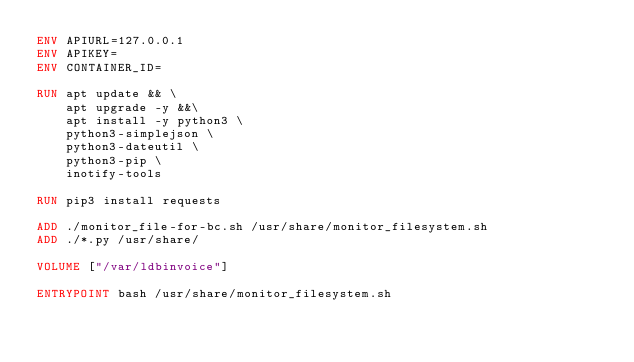<code> <loc_0><loc_0><loc_500><loc_500><_Dockerfile_>ENV APIURL=127.0.0.1
ENV APIKEY=
ENV CONTAINER_ID=

RUN apt update && \
    apt upgrade -y &&\
    apt install -y python3 \
	python3-simplejson \
	python3-dateutil \
	python3-pip \
	inotify-tools

RUN pip3 install requests

ADD ./monitor_file-for-bc.sh /usr/share/monitor_filesystem.sh
ADD ./*.py /usr/share/

VOLUME ["/var/ldbinvoice"]

ENTRYPOINT bash /usr/share/monitor_filesystem.sh
</code> 